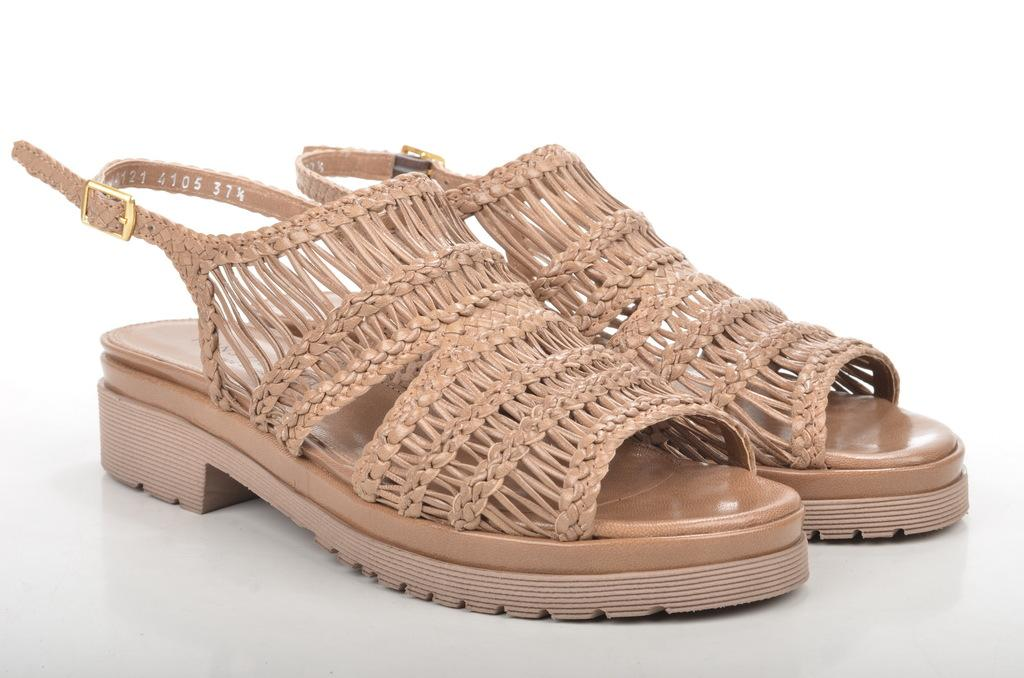What type of footwear can be seen in the image? There are pairs of sandals in the image. Where are the sandals located? The sandals are placed on a surface. Can you hear the impulse of the whistle in the image? There is no whistle present in the image, so it is not possible to hear any impulse. 